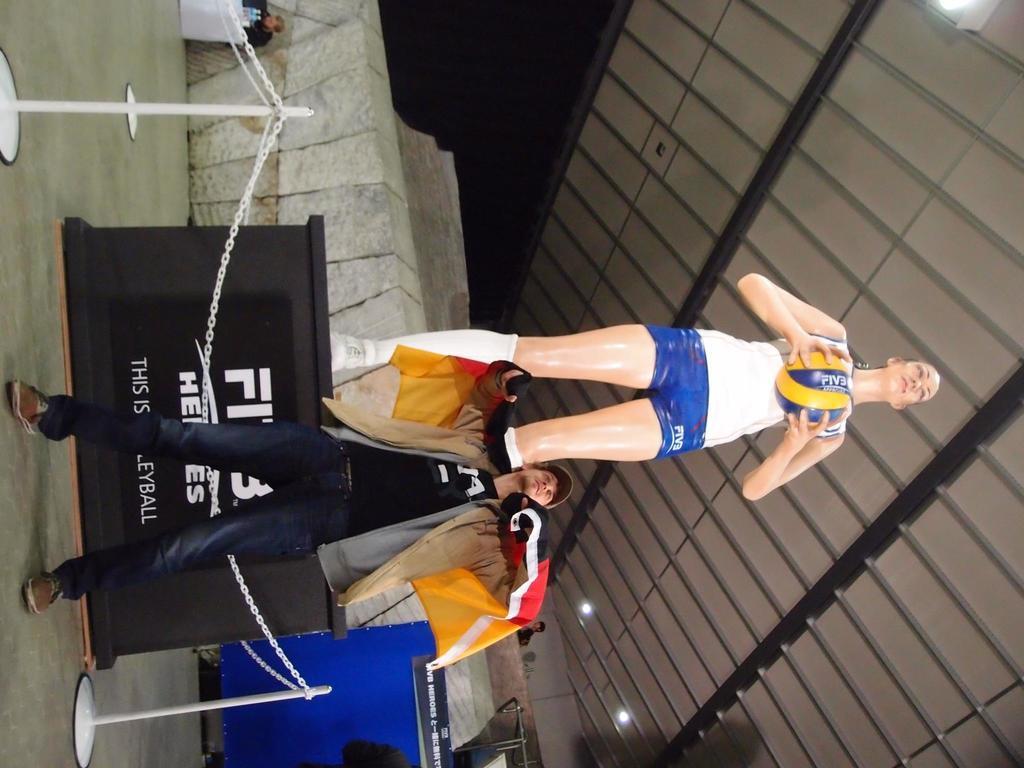Describe this image in one or two sentences. In this picture there is a statue of a woman standing and holding the ball and there is a man standing and there is text on the table. In the foreground there is a railing. At the back there is a person sitting behind the table and there are bottles on the table. At the top there are lights. At the back there is a person standing. At the bottom there is a floor. 